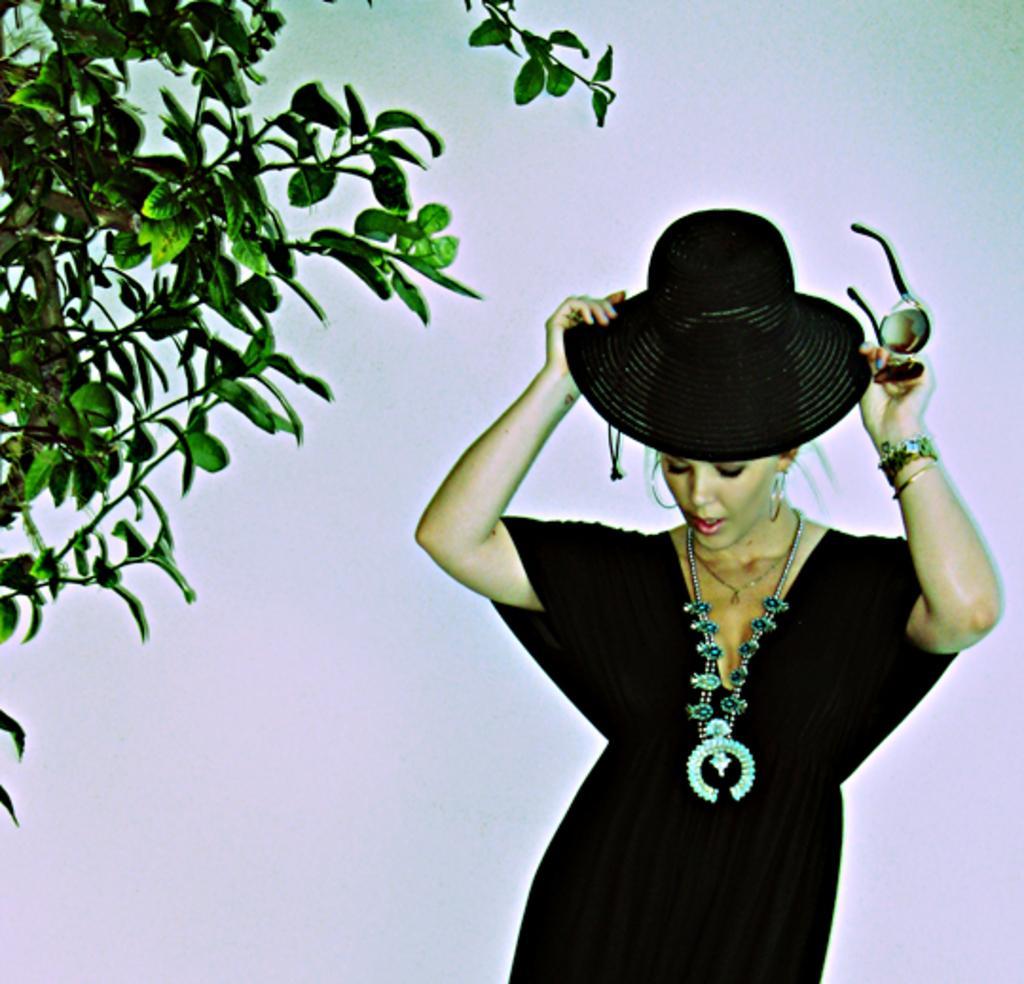Can you describe this image briefly? In this picture we can see a woman in the black dress and she is holding a hat and goggles. On the left side of the image there is a tree. Behind the woman there is the white background. 